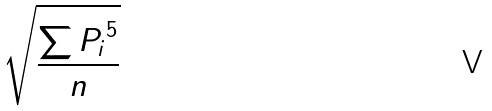Convert formula to latex. <formula><loc_0><loc_0><loc_500><loc_500>\sqrt { \frac { \sum { P _ { i } } ^ { 5 } } { n } }</formula> 